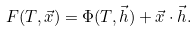<formula> <loc_0><loc_0><loc_500><loc_500>F ( T , \vec { x } ) = \Phi ( T , \vec { h } ) + \vec { x } \cdot \vec { h } .</formula> 